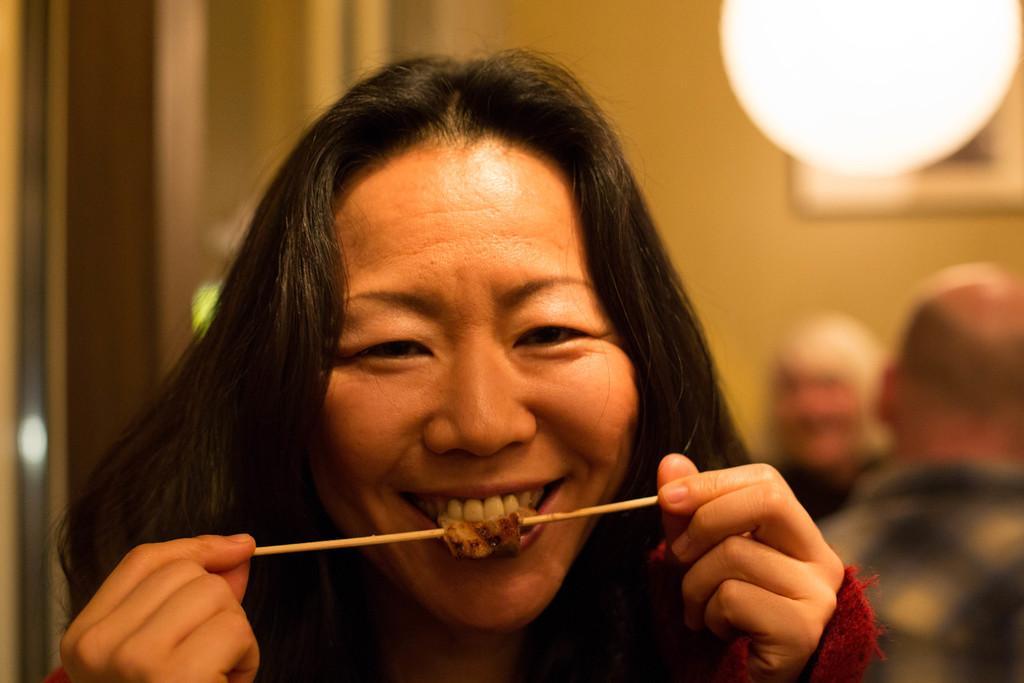Describe this image in one or two sentences. In this picture I can observe a woman. She is smiling. This woman is holding a stick in her hands. On the right side there are two persons. I can observe a light. In the background there is a wall. 